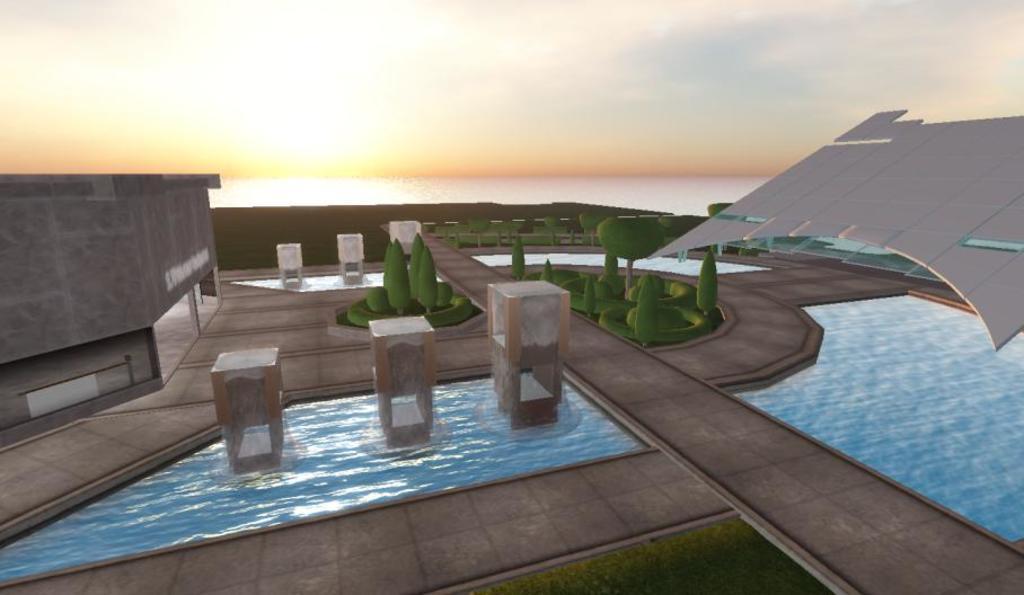Can you describe this image briefly? This is an animated image. In the foreground we can see the green grass and in background we can see the ground, trees, plants, water and a building and some other objects. In the background we can see the sky, which is sunny. 